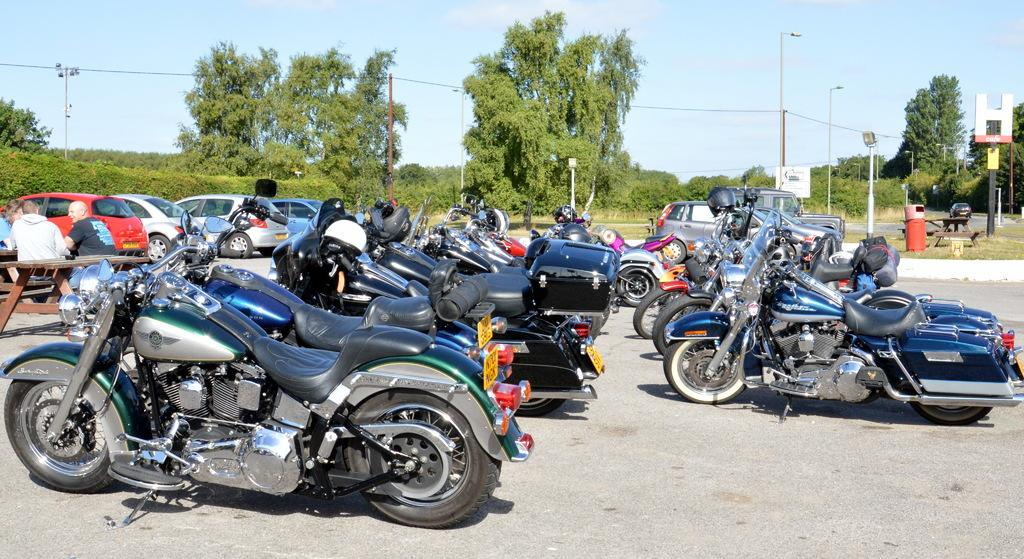What can be seen on the road in the image? There are vehicles on the road in the image. What are the people in the image doing? There are people sitting in the image. What type of vegetation is visible in the background of the image? There are trees in the background of the image. What is the color of the trees in the image? The trees are green in color. What other objects can be seen in the background of the image? There are light poles in the background of the image. What is the color of the sky in the image? The sky is white in color. Can you see any pipes in the image? There are no pipes present in the image. What type of scissors are being used by the people in the image? There are no scissors present in the image. 